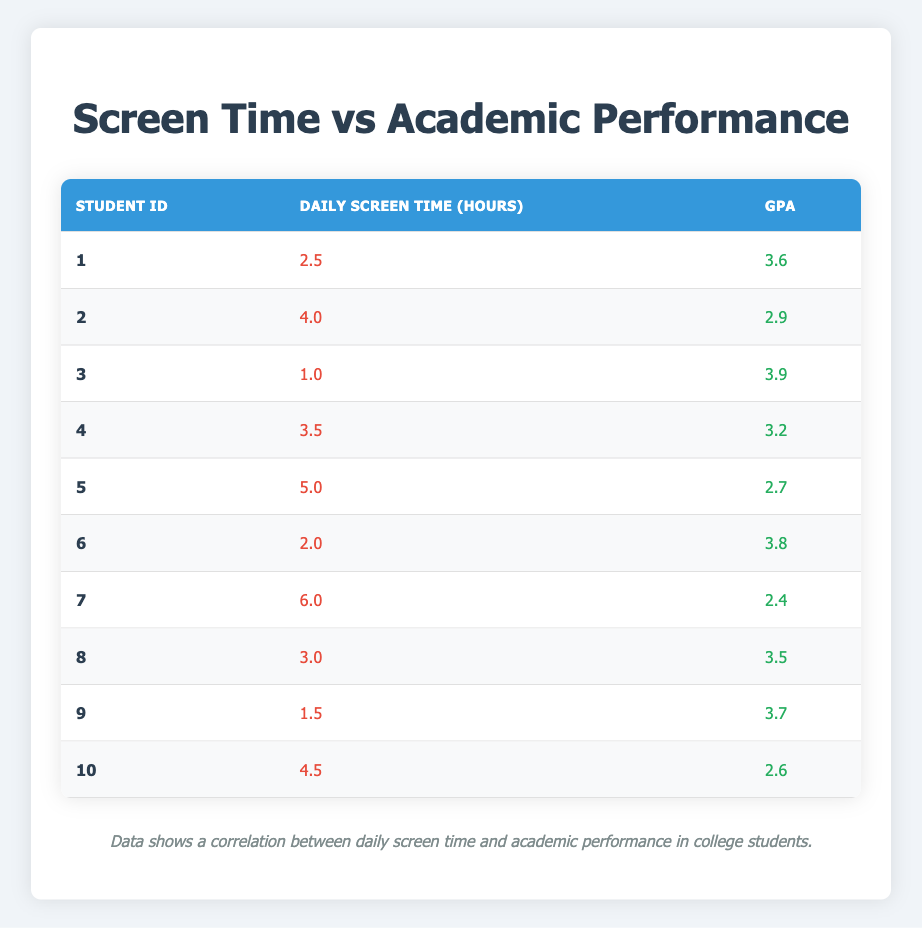What is the GPA of the student who spends the least amount of daily screen time? The student with the least amount of daily screen time is student 3, who spends 1.0 hours. The GPA for this student is listed in the table as 3.9.
Answer: 3.9 What is the total daily screen time of all students? To find the total daily screen time, add all the daily screen times: 2.5 + 4.0 + 1.0 + 3.5 + 5.0 + 2.0 + 6.0 + 3.0 + 1.5 + 4.5 = 33.0 hours.
Answer: 33.0 hours Is there any student with a GPA higher than 3.8 who spends more than 3 hours on daily screen time? Looking at the table, students 1 (3.6 GPA), 3 (3.9 GPA), and 6 (3.8 GPA) have GPAs higher than 3.8. However, student 3 spends 1.0 hour, student 1 spends 2.5 hours, and student 6 spends 2.0 hours. Therefore, there is no student fitting both criteria.
Answer: No What is the average GPA of students who spend 4 or more hours daily on screen time? The students who spend 4 or more hours are students 2 (2.9 GPA), 5 (2.7 GPA), 7 (2.4 GPA), and 10 (2.6 GPA). Adding these GPAs gives: 2.9 + 2.7 + 2.4 + 2.6 = 10.6. There are 4 students, so the average GPA is 10.6 / 4 = 2.65.
Answer: 2.65 Which student has the highest GPA and how many hours do they spend on screen time? Student 3 has the highest GPA at 3.9, and they spend 1.0 hour on daily screen time as listed in the table.
Answer: 1.0 hour What is the GPA difference between the student who spends the most and the least amount of daily screen time? The student who spends the most time is student 7 at 6.0 hours with a GPA of 2.4. The student who spends the least is student 3 at 1.0 hours with a GPA of 3.9. The GPA difference is 3.9 - 2.4 = 1.5.
Answer: 1.5 